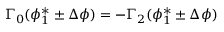Convert formula to latex. <formula><loc_0><loc_0><loc_500><loc_500>\Gamma _ { 0 } ( \phi _ { 1 } ^ { * } \pm \Delta \phi ) = - \Gamma _ { 2 } ( \phi _ { 1 } ^ { * } \pm \Delta \phi )</formula> 